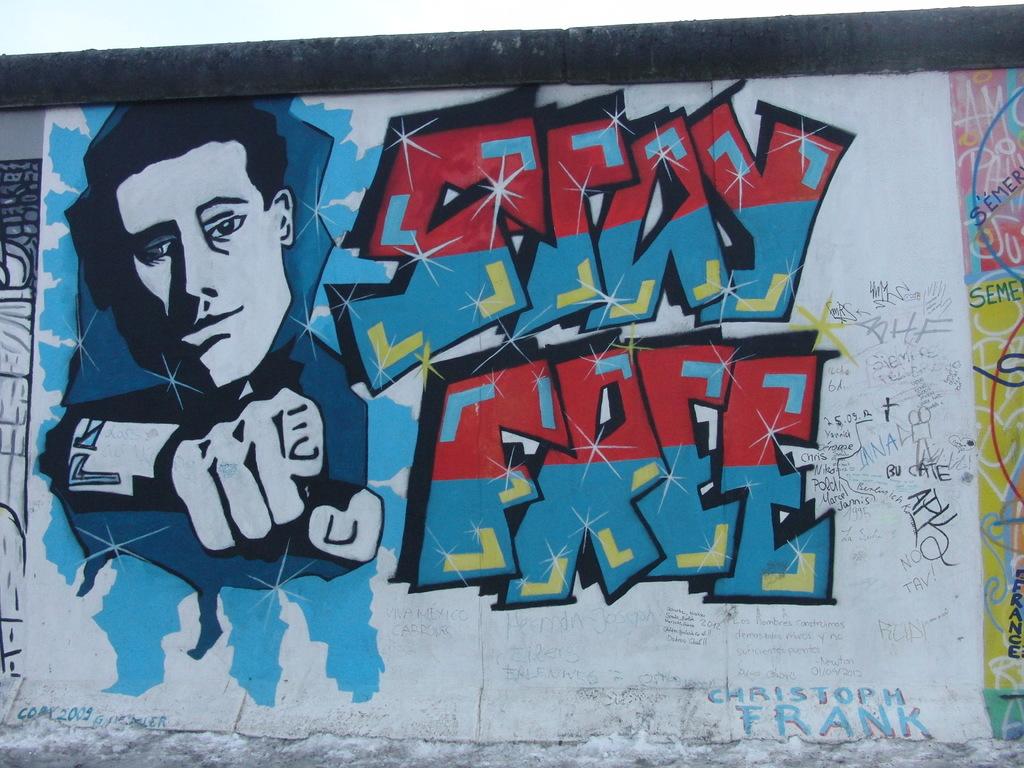What should you stay according to the image?
Offer a terse response. Free. What write this post?
Your response must be concise. Stay free. 